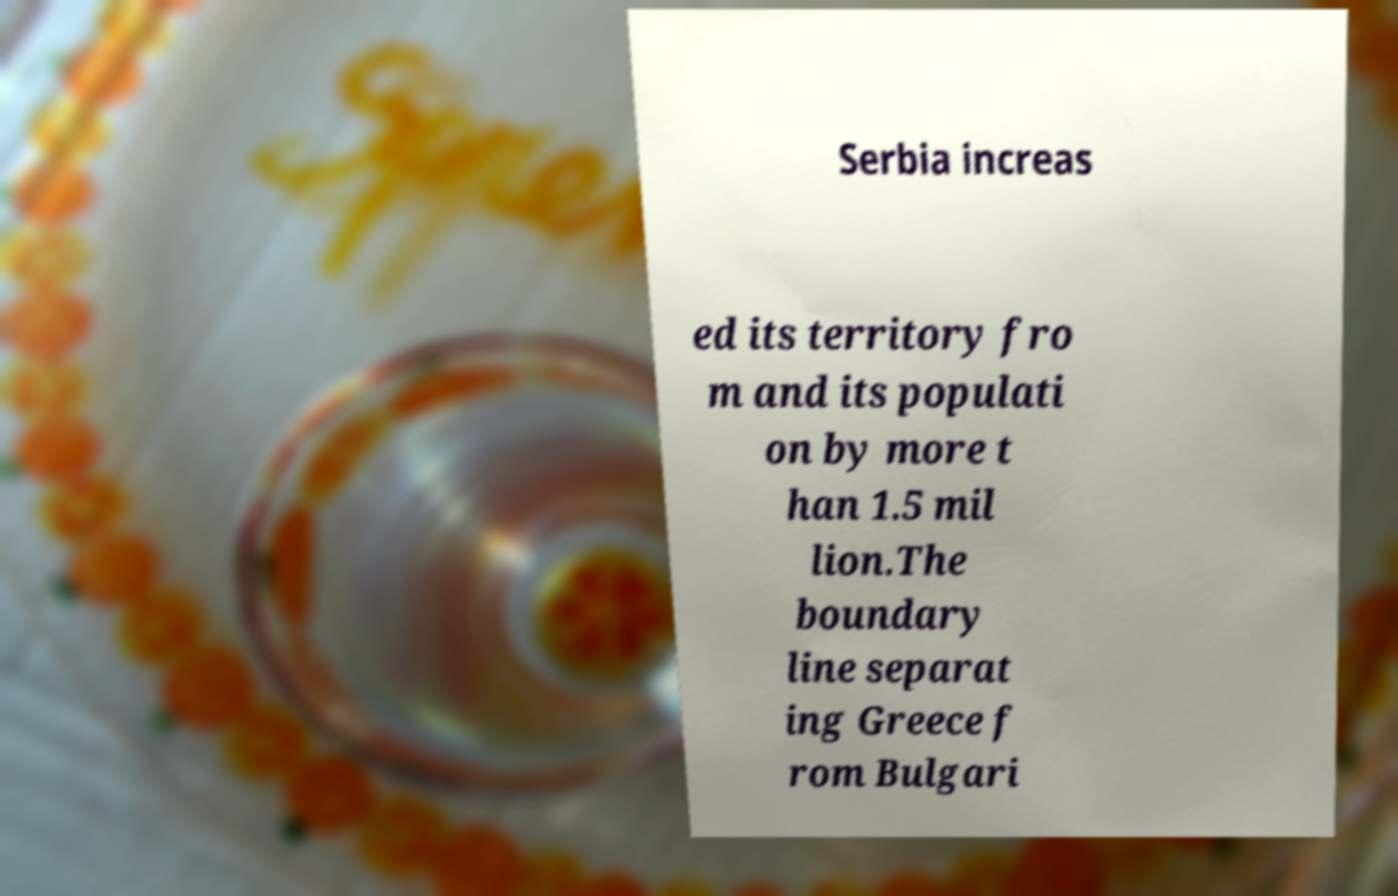Can you read and provide the text displayed in the image?This photo seems to have some interesting text. Can you extract and type it out for me? Serbia increas ed its territory fro m and its populati on by more t han 1.5 mil lion.The boundary line separat ing Greece f rom Bulgari 